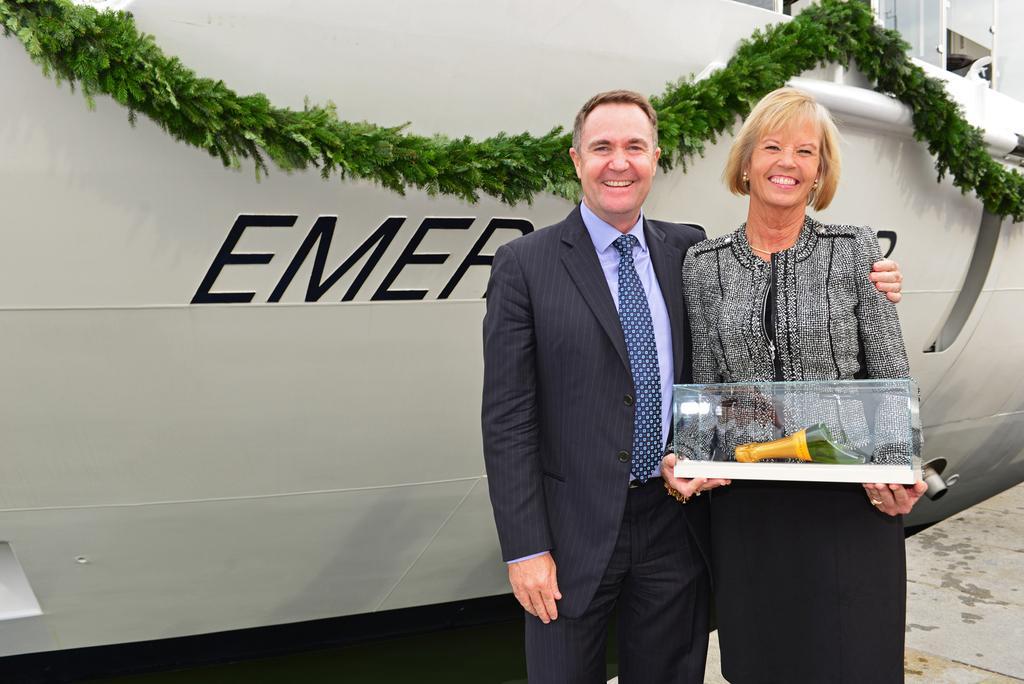How would you summarize this image in a sentence or two? In this image in the foreground there is one man and one woman who are standing and woman is holding a glass box. In the background there is some vehicle and a garland, at the bottom there is a floor. 